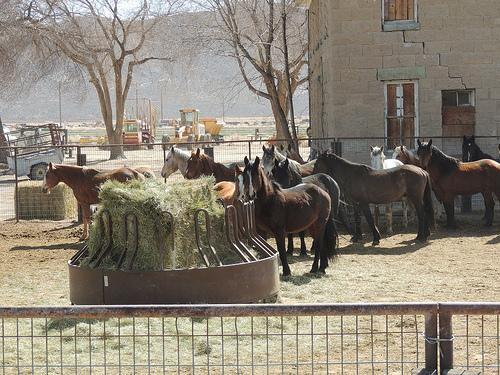Describe the geographic location and setting where the image takes place. The image showcases a farm near mountains, with horses in an enclosed pen, a stone-built building, and farm equipment nearby. Describe the type of structure in the background and mention its color and any distinguishable features. A white building made of stone blocks stands in the back of the horses, with a wood door and a visible crack on its surface. Point out any features of the horses that make them distinct from each other. Some horses are dark brown, while others are white or brown and white; one horse has a white strip on its face. Provide a brief description of the scene focusing on the animals present. A herd of brown and white horses, including one with a white strip on its face, is gathered in a pen, with some horses eating hay from a feeder. Give an account of the fencing around the horses and specify its material. The horses are enclosed within a metal wire fence with a bar across the top, which stretches from the left to the right side of the image. Mention the different types of trees in the image, and describe their appearance. There are bare trees without leaves scattered around the image, including a tall tree in front of the building and another in the middle of the grounds. Give a brief overview of the vehicles in the image and their colors. A short horse trailer is located near the left side of the image and the back of a white pickup truck can be seen on the bottom left. Identify the type of farm equipment present in the image and describe its color. There is a yellow grader sitting on a road in the middle part of the image, slightly to the left. Mention the position and appearance of the largest tree in the image. A large bare tree without leaves is located in the left-top corner of the image, with part of its branches extending to the right. Briefly describe the state of the ground and the items scattered around it. The ground is covered with hay, while a bale of hay is also present near the fence, along with hay in feeders, a barrel, and a cement and metal container. 